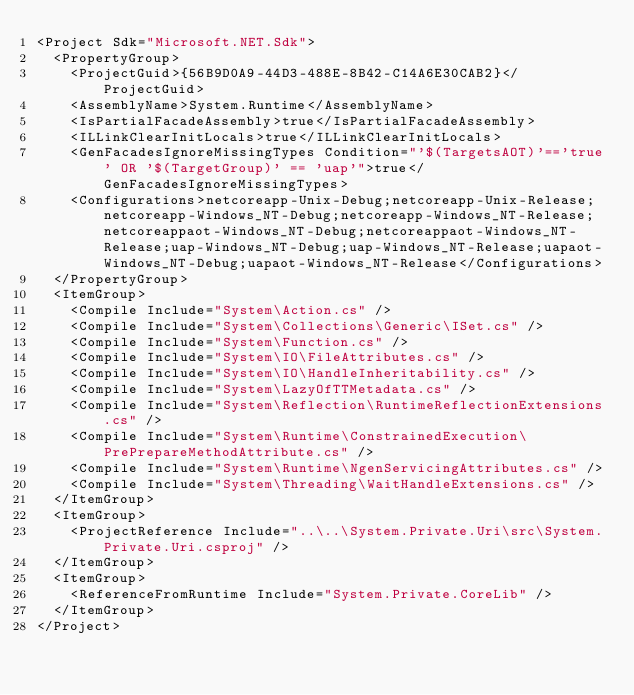<code> <loc_0><loc_0><loc_500><loc_500><_XML_><Project Sdk="Microsoft.NET.Sdk">
  <PropertyGroup>
    <ProjectGuid>{56B9D0A9-44D3-488E-8B42-C14A6E30CAB2}</ProjectGuid>
    <AssemblyName>System.Runtime</AssemblyName>
    <IsPartialFacadeAssembly>true</IsPartialFacadeAssembly>
    <ILLinkClearInitLocals>true</ILLinkClearInitLocals>
    <GenFacadesIgnoreMissingTypes Condition="'$(TargetsAOT)'=='true' OR '$(TargetGroup)' == 'uap'">true</GenFacadesIgnoreMissingTypes>
    <Configurations>netcoreapp-Unix-Debug;netcoreapp-Unix-Release;netcoreapp-Windows_NT-Debug;netcoreapp-Windows_NT-Release;netcoreappaot-Windows_NT-Debug;netcoreappaot-Windows_NT-Release;uap-Windows_NT-Debug;uap-Windows_NT-Release;uapaot-Windows_NT-Debug;uapaot-Windows_NT-Release</Configurations>
  </PropertyGroup>
  <ItemGroup>
    <Compile Include="System\Action.cs" />
    <Compile Include="System\Collections\Generic\ISet.cs" />
    <Compile Include="System\Function.cs" />
    <Compile Include="System\IO\FileAttributes.cs" />
    <Compile Include="System\IO\HandleInheritability.cs" />
    <Compile Include="System\LazyOfTTMetadata.cs" />
    <Compile Include="System\Reflection\RuntimeReflectionExtensions.cs" />
    <Compile Include="System\Runtime\ConstrainedExecution\PrePrepareMethodAttribute.cs" />
    <Compile Include="System\Runtime\NgenServicingAttributes.cs" />
    <Compile Include="System\Threading\WaitHandleExtensions.cs" />
  </ItemGroup>
  <ItemGroup>
    <ProjectReference Include="..\..\System.Private.Uri\src\System.Private.Uri.csproj" />
  </ItemGroup>
  <ItemGroup>
    <ReferenceFromRuntime Include="System.Private.CoreLib" />
  </ItemGroup>
</Project></code> 